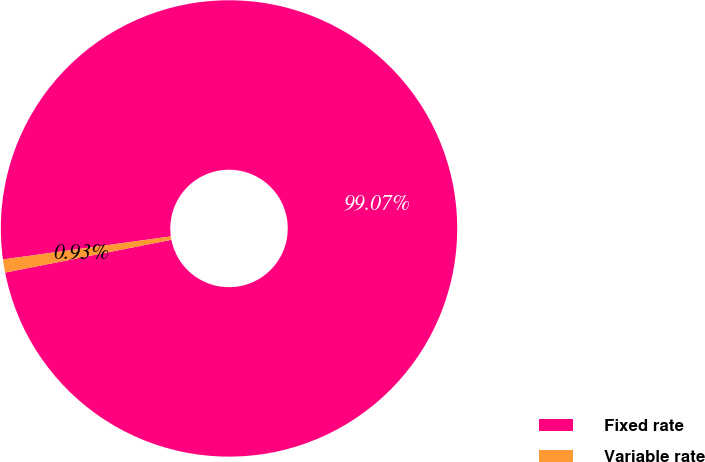<chart> <loc_0><loc_0><loc_500><loc_500><pie_chart><fcel>Fixed rate<fcel>Variable rate<nl><fcel>99.07%<fcel>0.93%<nl></chart> 